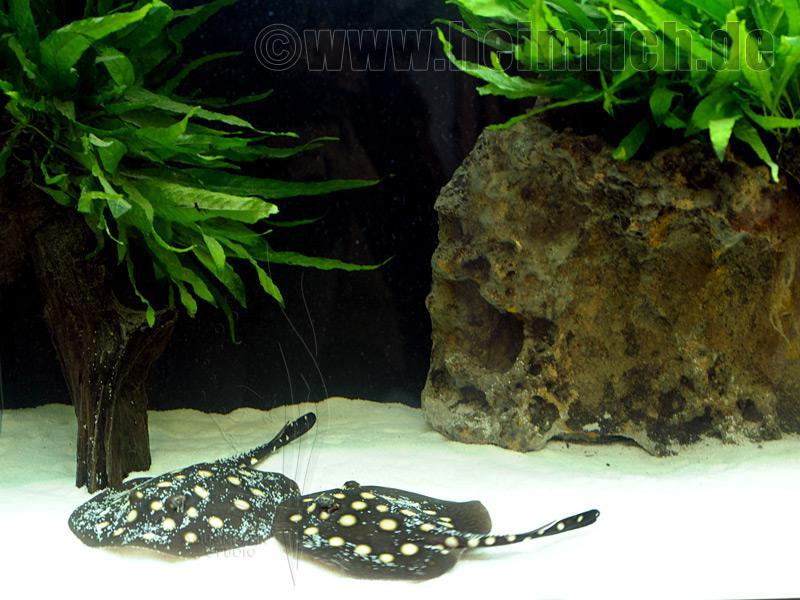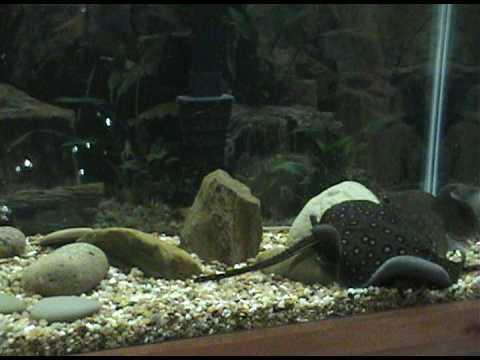The first image is the image on the left, the second image is the image on the right. Analyze the images presented: Is the assertion "There are exactly three stingrays." valid? Answer yes or no. Yes. 